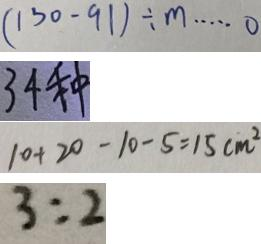<formula> <loc_0><loc_0><loc_500><loc_500>( 1 3 0 - 9 1 ) \div m \cdots 0 
 3 4 种 
 1 0 + 2 0 - 1 0 - 5 = 1 5 c m ^ { 2 } 
 3 : 2</formula> 